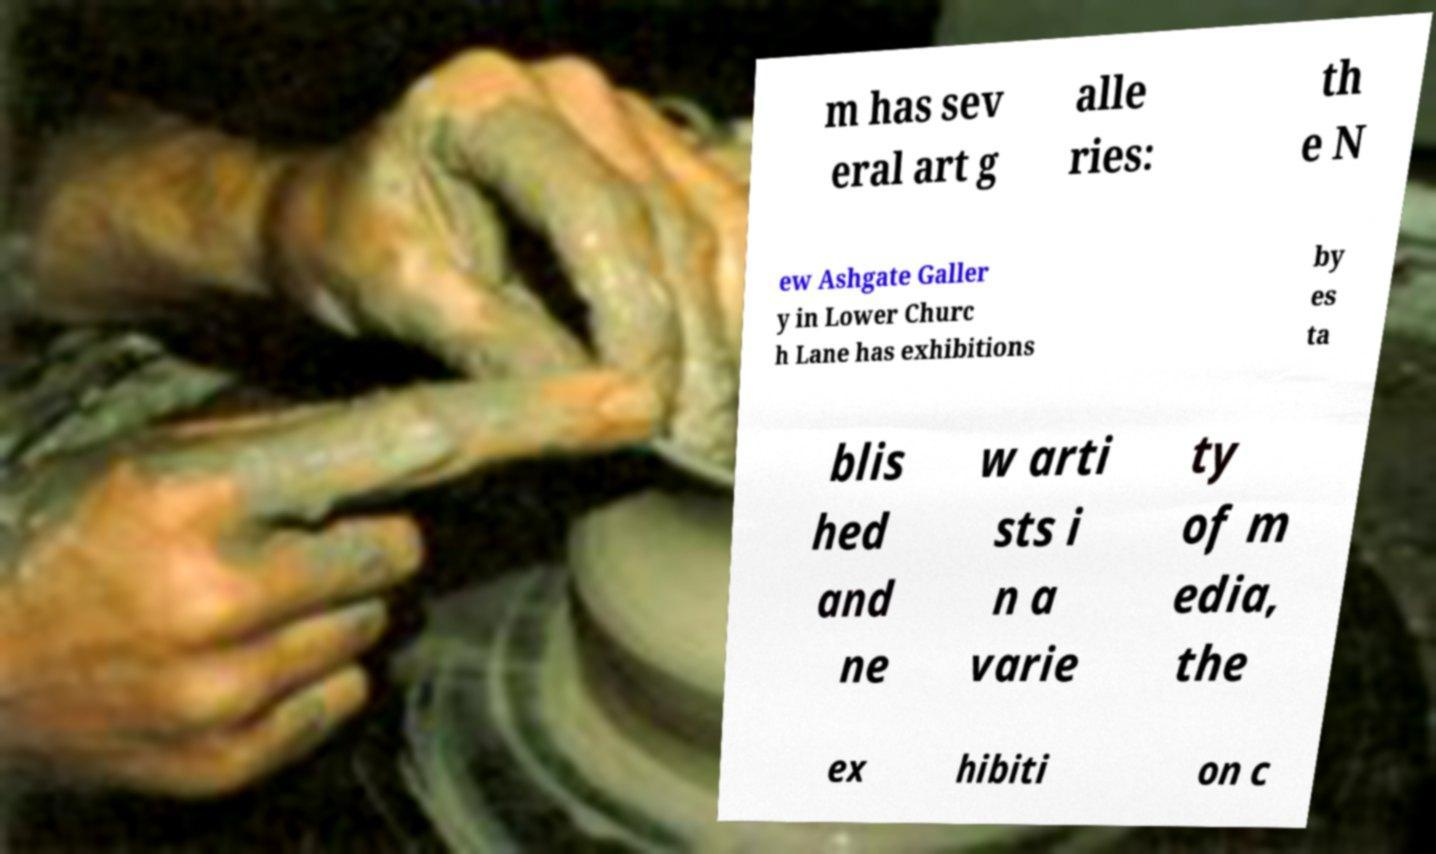What messages or text are displayed in this image? I need them in a readable, typed format. m has sev eral art g alle ries: th e N ew Ashgate Galler y in Lower Churc h Lane has exhibitions by es ta blis hed and ne w arti sts i n a varie ty of m edia, the ex hibiti on c 